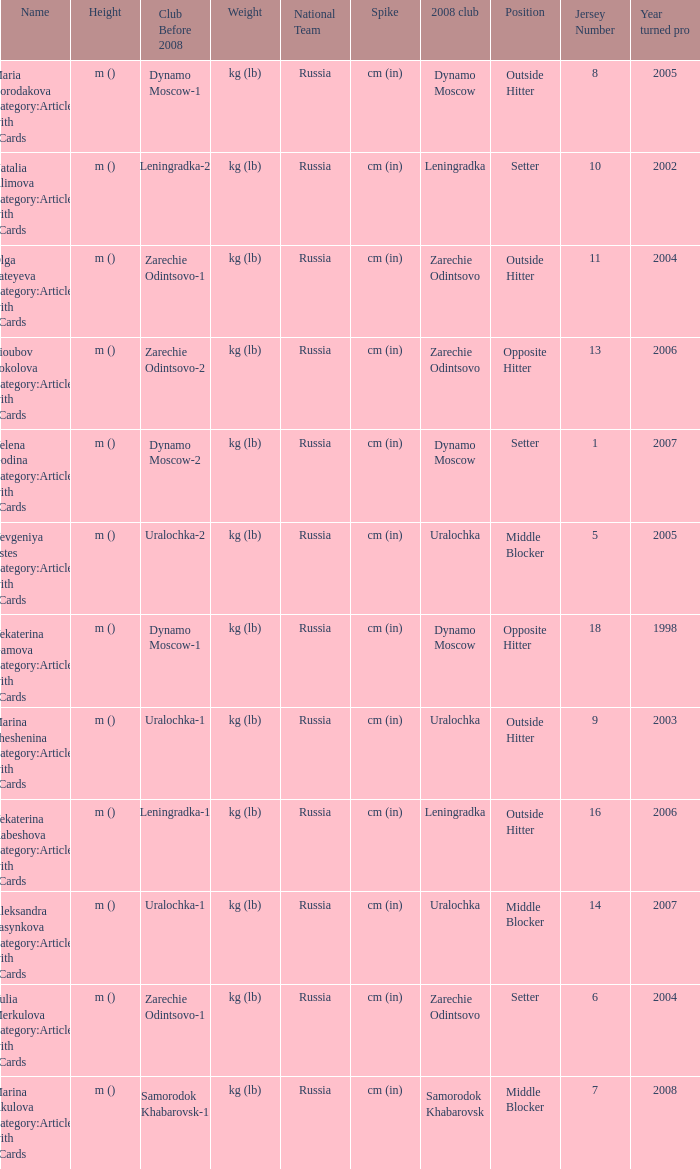Could you help me parse every detail presented in this table? {'header': ['Name', 'Height', 'Club Before 2008', 'Weight', 'National Team', 'Spike', '2008 club', 'Position', 'Jersey Number', 'Year turned pro'], 'rows': [['Maria Borodakova Category:Articles with hCards', 'm ()', 'Dynamo Moscow-1', 'kg (lb)', 'Russia', 'cm (in)', 'Dynamo Moscow', 'Outside Hitter', '8', '2005'], ['Natalia Alimova Category:Articles with hCards', 'm ()', 'Leningradka-2', 'kg (lb)', 'Russia', 'cm (in)', 'Leningradka', 'Setter', '10', '2002'], ['Olga Fateyeva Category:Articles with hCards', 'm ()', 'Zarechie Odintsovo-1', 'kg (lb)', 'Russia', 'cm (in)', 'Zarechie Odintsovo', 'Outside Hitter', '11', '2004'], ['Lioubov Sokolova Category:Articles with hCards', 'm ()', 'Zarechie Odintsovo-2', 'kg (lb)', 'Russia', 'cm (in)', 'Zarechie Odintsovo', 'Opposite Hitter', '13', '2006'], ['Yelena Godina Category:Articles with hCards', 'm ()', 'Dynamo Moscow-2', 'kg (lb)', 'Russia', 'cm (in)', 'Dynamo Moscow', 'Setter', '1', '2007'], ['Yevgeniya Estes Category:Articles with hCards', 'm ()', 'Uralochka-2', 'kg (lb)', 'Russia', 'cm (in)', 'Uralochka', 'Middle Blocker', '5', '2005'], ['Yekaterina Gamova Category:Articles with hCards', 'm ()', 'Dynamo Moscow-1', 'kg (lb)', 'Russia', 'cm (in)', 'Dynamo Moscow', 'Opposite Hitter', '18', '1998'], ['Marina Sheshenina Category:Articles with hCards', 'm ()', 'Uralochka-1', 'kg (lb)', 'Russia', 'cm (in)', 'Uralochka', 'Outside Hitter', '9', '2003'], ['Yekaterina Kabeshova Category:Articles with hCards', 'm ()', 'Leningradka-1', 'kg (lb)', 'Russia', 'cm (in)', 'Leningradka', 'Outside Hitter', '16', '2006'], ['Aleksandra Pasynkova Category:Articles with hCards', 'm ()', 'Uralochka-1', 'kg (lb)', 'Russia', 'cm (in)', 'Uralochka', 'Middle Blocker', '14', '2007'], ['Yulia Merkulova Category:Articles with hCards', 'm ()', 'Zarechie Odintsovo-1', 'kg (lb)', 'Russia', 'cm (in)', 'Zarechie Odintsovo', 'Setter', '6', '2004'], ['Marina Akulova Category:Articles with hCards', 'm ()', 'Samorodok Khabarovsk-1', 'kg (lb)', 'Russia', 'cm (in)', 'Samorodok Khabarovsk', 'Middle Blocker', '7', '2008']]} What is the name when the 2008 club is uralochka? Yevgeniya Estes Category:Articles with hCards, Marina Sheshenina Category:Articles with hCards, Aleksandra Pasynkova Category:Articles with hCards. 